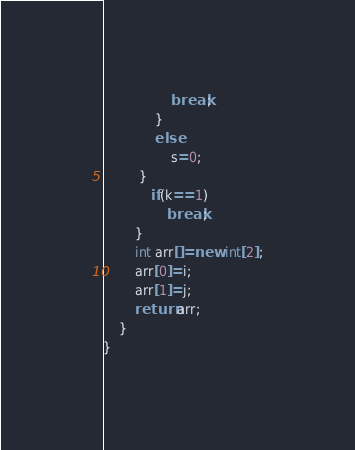<code> <loc_0><loc_0><loc_500><loc_500><_Java_>                 break;
             }
             else
                 s=0;
         }
            if(k==1)
                break;
        }
        int arr[]=new int[2];
        arr[0]=i;
        arr[1]=j;
        return arr;
    }
}</code> 